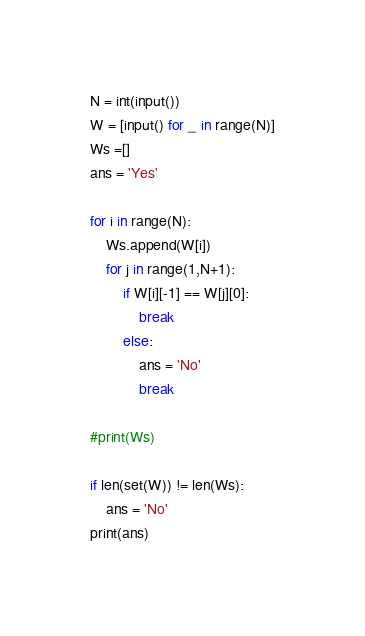Convert code to text. <code><loc_0><loc_0><loc_500><loc_500><_Python_>N = int(input())
W = [input() for _ in range(N)]
Ws =[]
ans = 'Yes'

for i in range(N):
    Ws.append(W[i])
    for j in range(1,N+1):
        if W[i][-1] == W[j][0]:
            break
        else:
            ans = 'No'
            break
        
#print(Ws)

if len(set(W)) != len(Ws):
    ans = 'No'
print(ans)  </code> 